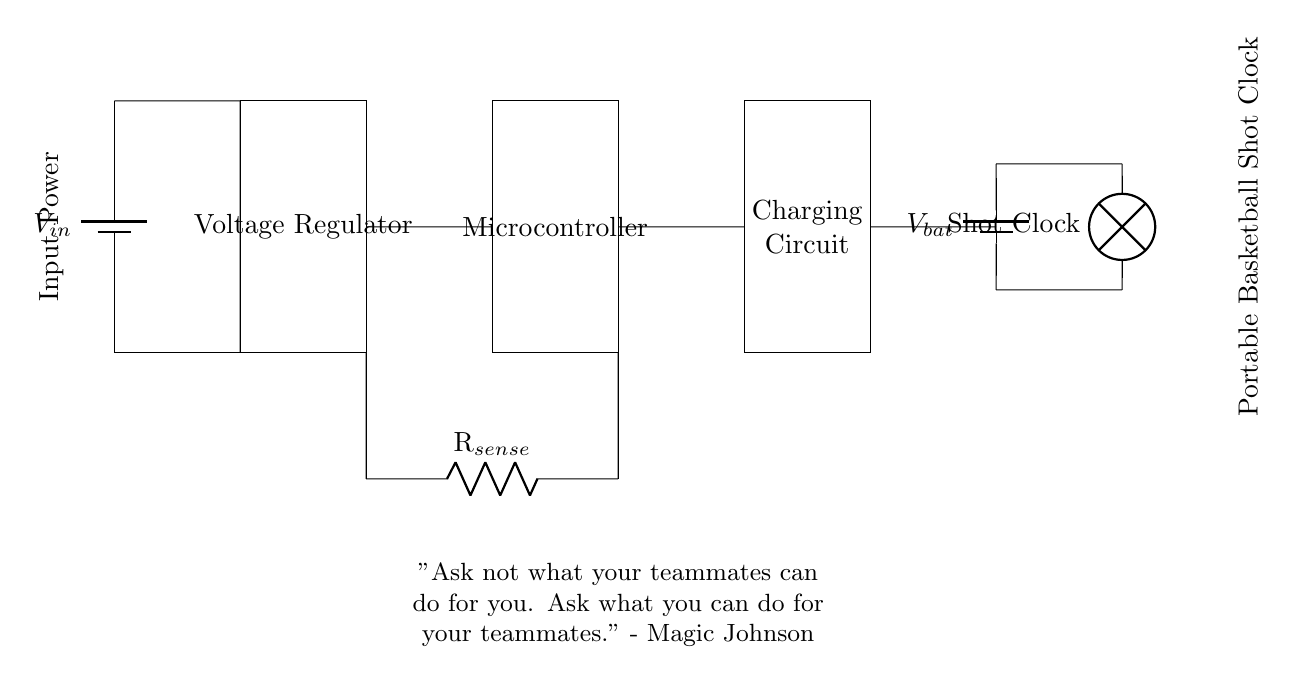What is the input power source in the circuit? The input power source in the circuit is represented as a battery labeled V in, which provides electrical energy to the circuit.
Answer: V in What is the role of the voltage regulator? The voltage regulator in the circuit stabilizes the voltage coming from the input power source, ensuring the microcontroller and other components receive a consistent voltage level.
Answer: Stabilizes voltage What type of load is connected to the battery? The load connected to the battery is a lamp representing the shot clock, which indicates it is an electric device that uses power from the battery.
Answer: Shot clock How many main components are in the charging circuit? The charging circuit contains four main components: the battery, voltage regulator, microcontroller, and charging circuit itself. By counting these distinct rectangles in the circuit, you can determine the number.
Answer: Four What does the current sense resistor do? The current sense resistor measures the amount of current flowing within the circuit, which allows for monitoring the charging status and performance of the battery.
Answer: Measures current What is the potential difference across the battery? The potential difference across the battery is represented as V bat, which indicates the voltage supplied by the battery to the load and circuit.
Answer: V bat What analogy can we draw from Magic Johnson's quote in relation to teamwork in this circuit? Magic Johnson's quote emphasizes teamwork; similarly, all components in the circuit must work together—like teammates—to ensure the portable basketball shot clock functions properly. Each component plays a vital role in delivering power and functionality.
Answer: Teamwork analogy 